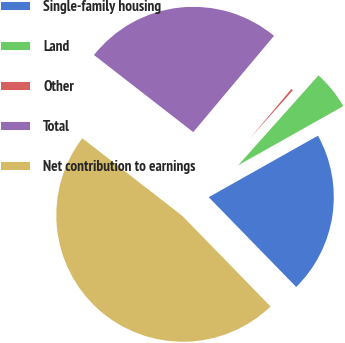<chart> <loc_0><loc_0><loc_500><loc_500><pie_chart><fcel>Single-family housing<fcel>Land<fcel>Other<fcel>Total<fcel>Net contribution to earnings<nl><fcel>20.87%<fcel>5.23%<fcel>0.5%<fcel>25.6%<fcel>47.8%<nl></chart> 